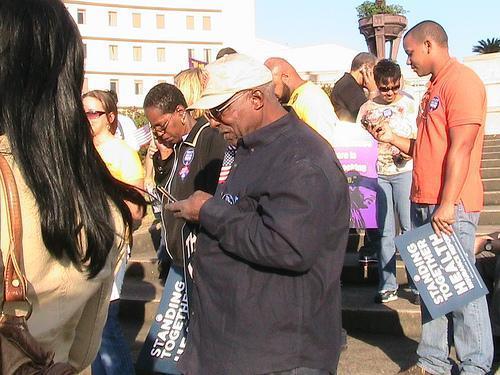How many people are holding signs?
Give a very brief answer. 3. 